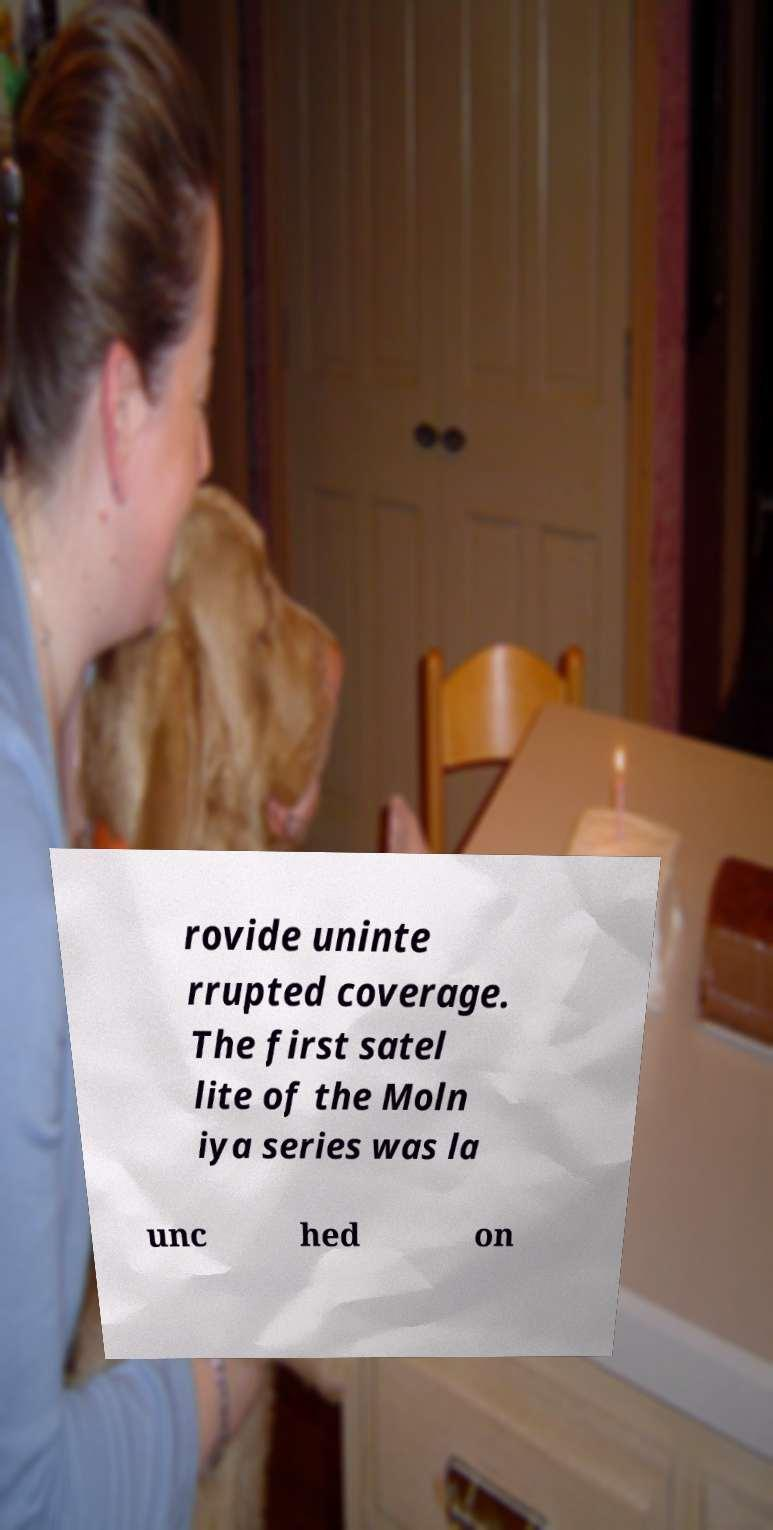I need the written content from this picture converted into text. Can you do that? rovide uninte rrupted coverage. The first satel lite of the Moln iya series was la unc hed on 